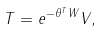Convert formula to latex. <formula><loc_0><loc_0><loc_500><loc_500>T = e ^ { - \theta ^ { T } W } V ,</formula> 